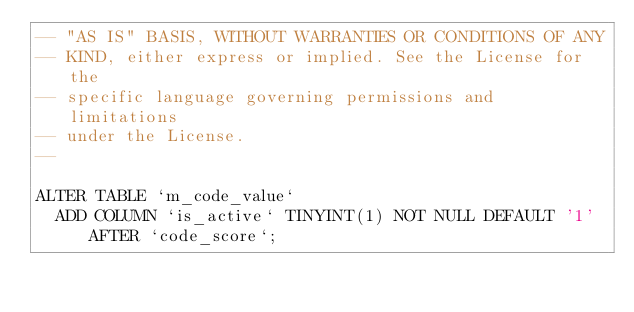Convert code to text. <code><loc_0><loc_0><loc_500><loc_500><_SQL_>-- "AS IS" BASIS, WITHOUT WARRANTIES OR CONDITIONS OF ANY
-- KIND, either express or implied. See the License for the
-- specific language governing permissions and limitations
-- under the License.
--

ALTER TABLE `m_code_value`
	ADD COLUMN `is_active` TINYINT(1) NOT NULL DEFAULT '1' AFTER `code_score`;
</code> 